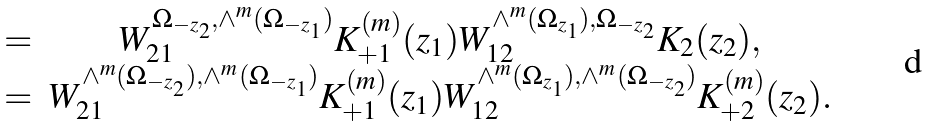<formula> <loc_0><loc_0><loc_500><loc_500>\begin{array} { c c } = & W _ { 2 1 } ^ { \Omega _ { - z _ { 2 } } , \wedge ^ { m } ( \Omega _ { - z _ { 1 } } ) } K _ { + 1 } ^ { ( m ) } ( z _ { 1 } ) W _ { 1 2 } ^ { \wedge ^ { m } ( \Omega _ { z _ { 1 } } ) , \Omega _ { - z _ { 2 } } } K _ { 2 } ( z _ { 2 } ) , \\ = & W _ { 2 1 } ^ { \wedge ^ { m } ( \Omega _ { - z _ { 2 } } ) , \wedge ^ { m } ( \Omega _ { - z _ { 1 } } ) } K _ { + 1 } ^ { ( m ) } ( z _ { 1 } ) W _ { 1 2 } ^ { \wedge ^ { m } ( \Omega _ { z _ { 1 } } ) , \wedge ^ { m } ( \Omega _ { - z _ { 2 } } ) } K _ { + 2 } ^ { ( m ) } ( z _ { 2 } ) . \end{array}</formula> 